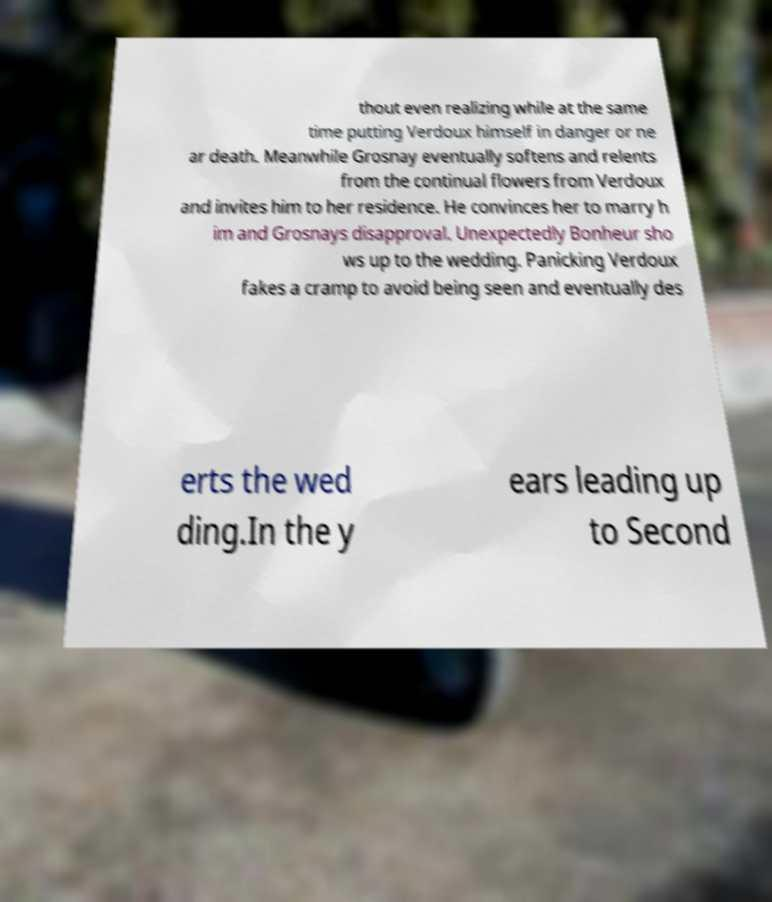For documentation purposes, I need the text within this image transcribed. Could you provide that? thout even realizing while at the same time putting Verdoux himself in danger or ne ar death. Meanwhile Grosnay eventually softens and relents from the continual flowers from Verdoux and invites him to her residence. He convinces her to marry h im and Grosnays disapproval. Unexpectedly Bonheur sho ws up to the wedding. Panicking Verdoux fakes a cramp to avoid being seen and eventually des erts the wed ding.In the y ears leading up to Second 